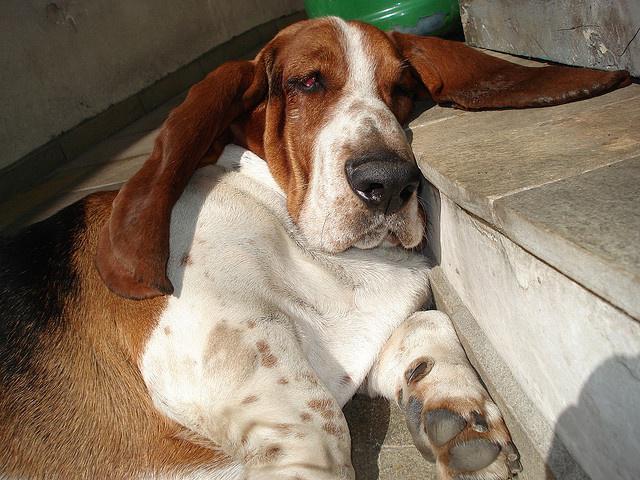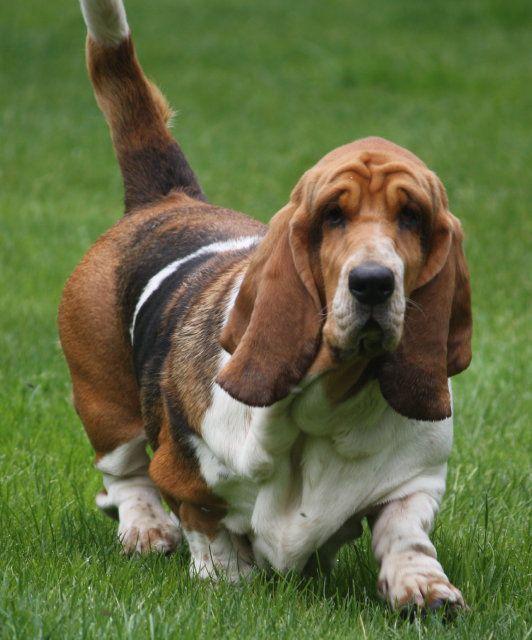The first image is the image on the left, the second image is the image on the right. Given the left and right images, does the statement "There are three dogs." hold true? Answer yes or no. No. The first image is the image on the left, the second image is the image on the right. For the images displayed, is the sentence "There are at least two dogs walking in the same direction." factually correct? Answer yes or no. No. 